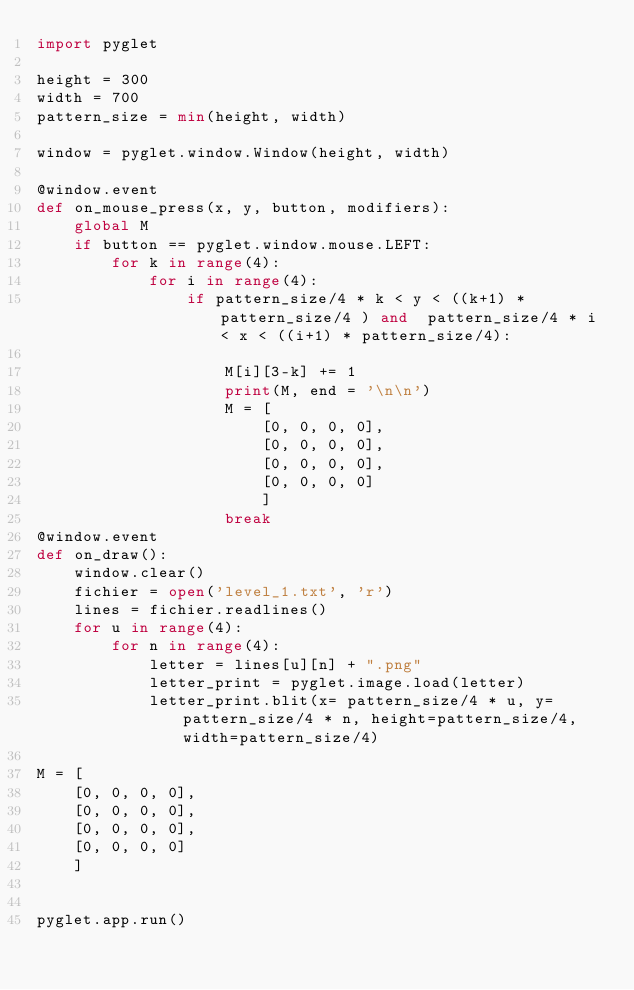Convert code to text. <code><loc_0><loc_0><loc_500><loc_500><_Python_>import pyglet

height = 300
width = 700
pattern_size = min(height, width)

window = pyglet.window.Window(height, width)

@window.event
def on_mouse_press(x, y, button, modifiers):
    global M
    if button == pyglet.window.mouse.LEFT:
        for k in range(4):
            for i in range(4):
                if pattern_size/4 * k < y < ((k+1) * pattern_size/4 ) and  pattern_size/4 * i < x < ((i+1) * pattern_size/4):
                    
                    M[i][3-k] += 1
                    print(M, end = '\n\n')
                    M = [
                        [0, 0, 0, 0],
                        [0, 0, 0, 0],
                        [0, 0, 0, 0],
                        [0, 0, 0, 0]
                        ]
                    break
@window.event
def on_draw():
    window.clear()
    fichier = open('level_1.txt', 'r')
    lines = fichier.readlines()
    for u in range(4):
        for n in range(4):
            letter = lines[u][n] + ".png"
            letter_print = pyglet.image.load(letter)               
            letter_print.blit(x= pattern_size/4 * u, y=pattern_size/4 * n, height=pattern_size/4, width=pattern_size/4)

M = [
    [0, 0, 0, 0],
    [0, 0, 0, 0],
    [0, 0, 0, 0],
    [0, 0, 0, 0]
    ]


pyglet.app.run()
</code> 